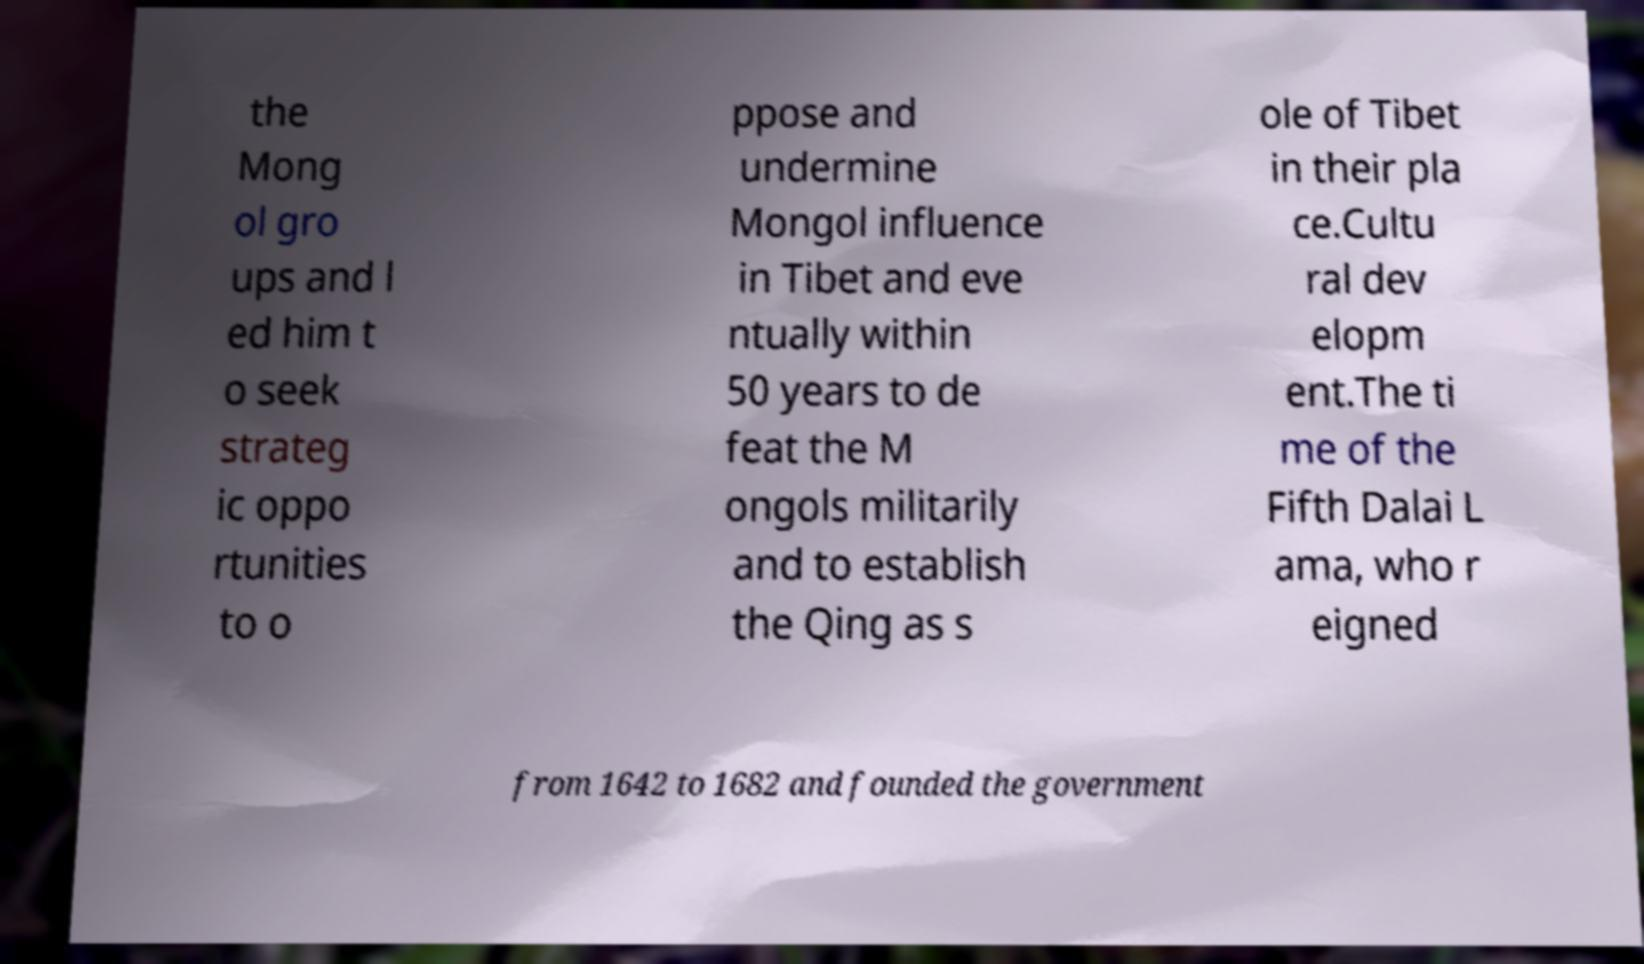Please read and relay the text visible in this image. What does it say? the Mong ol gro ups and l ed him t o seek strateg ic oppo rtunities to o ppose and undermine Mongol influence in Tibet and eve ntually within 50 years to de feat the M ongols militarily and to establish the Qing as s ole of Tibet in their pla ce.Cultu ral dev elopm ent.The ti me of the Fifth Dalai L ama, who r eigned from 1642 to 1682 and founded the government 